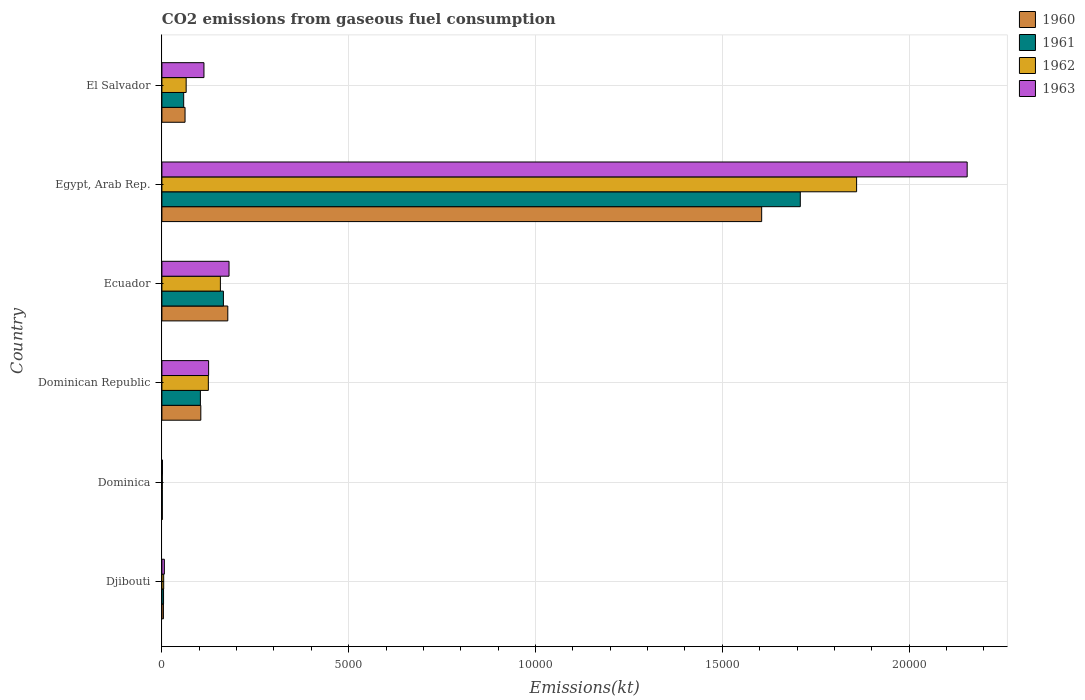How many bars are there on the 4th tick from the bottom?
Ensure brevity in your answer.  4. What is the label of the 1st group of bars from the top?
Provide a succinct answer. El Salvador. What is the amount of CO2 emitted in 1960 in Dominican Republic?
Your answer should be very brief. 1041.43. Across all countries, what is the maximum amount of CO2 emitted in 1960?
Offer a very short reply. 1.61e+04. Across all countries, what is the minimum amount of CO2 emitted in 1961?
Provide a succinct answer. 11. In which country was the amount of CO2 emitted in 1961 maximum?
Your answer should be very brief. Egypt, Arab Rep. In which country was the amount of CO2 emitted in 1963 minimum?
Your answer should be compact. Dominica. What is the total amount of CO2 emitted in 1962 in the graph?
Make the answer very short. 2.21e+04. What is the difference between the amount of CO2 emitted in 1961 in Dominican Republic and that in El Salvador?
Keep it short and to the point. 447.37. What is the difference between the amount of CO2 emitted in 1961 in Dominican Republic and the amount of CO2 emitted in 1963 in El Salvador?
Give a very brief answer. -95.34. What is the average amount of CO2 emitted in 1962 per country?
Your answer should be very brief. 3685.34. What is the difference between the amount of CO2 emitted in 1960 and amount of CO2 emitted in 1962 in Dominican Republic?
Offer a very short reply. -201.68. In how many countries, is the amount of CO2 emitted in 1961 greater than 11000 kt?
Give a very brief answer. 1. What is the ratio of the amount of CO2 emitted in 1963 in Dominican Republic to that in El Salvador?
Provide a short and direct response. 1.11. Is the amount of CO2 emitted in 1960 in Djibouti less than that in El Salvador?
Provide a short and direct response. Yes. What is the difference between the highest and the second highest amount of CO2 emitted in 1960?
Your answer should be compact. 1.43e+04. What is the difference between the highest and the lowest amount of CO2 emitted in 1960?
Make the answer very short. 1.60e+04. In how many countries, is the amount of CO2 emitted in 1960 greater than the average amount of CO2 emitted in 1960 taken over all countries?
Your answer should be compact. 1. Is it the case that in every country, the sum of the amount of CO2 emitted in 1960 and amount of CO2 emitted in 1962 is greater than the sum of amount of CO2 emitted in 1961 and amount of CO2 emitted in 1963?
Ensure brevity in your answer.  No. What does the 1st bar from the bottom in Ecuador represents?
Offer a terse response. 1960. Is it the case that in every country, the sum of the amount of CO2 emitted in 1963 and amount of CO2 emitted in 1960 is greater than the amount of CO2 emitted in 1962?
Offer a very short reply. Yes. Are all the bars in the graph horizontal?
Your answer should be very brief. Yes. Does the graph contain any zero values?
Your response must be concise. No. Does the graph contain grids?
Keep it short and to the point. Yes. How many legend labels are there?
Your answer should be compact. 4. How are the legend labels stacked?
Keep it short and to the point. Vertical. What is the title of the graph?
Keep it short and to the point. CO2 emissions from gaseous fuel consumption. What is the label or title of the X-axis?
Your answer should be compact. Emissions(kt). What is the Emissions(kt) of 1960 in Djibouti?
Make the answer very short. 40.34. What is the Emissions(kt) in 1961 in Djibouti?
Offer a terse response. 44. What is the Emissions(kt) in 1962 in Djibouti?
Your response must be concise. 47.67. What is the Emissions(kt) of 1963 in Djibouti?
Keep it short and to the point. 66.01. What is the Emissions(kt) in 1960 in Dominica?
Make the answer very short. 11. What is the Emissions(kt) in 1961 in Dominica?
Provide a short and direct response. 11. What is the Emissions(kt) in 1962 in Dominica?
Make the answer very short. 11. What is the Emissions(kt) of 1963 in Dominica?
Your answer should be very brief. 14.67. What is the Emissions(kt) in 1960 in Dominican Republic?
Keep it short and to the point. 1041.43. What is the Emissions(kt) of 1961 in Dominican Republic?
Offer a very short reply. 1030.43. What is the Emissions(kt) in 1962 in Dominican Republic?
Your answer should be very brief. 1243.11. What is the Emissions(kt) of 1963 in Dominican Republic?
Provide a succinct answer. 1250.45. What is the Emissions(kt) in 1960 in Ecuador?
Give a very brief answer. 1763.83. What is the Emissions(kt) of 1961 in Ecuador?
Offer a terse response. 1646.48. What is the Emissions(kt) of 1962 in Ecuador?
Your answer should be compact. 1565.81. What is the Emissions(kt) in 1963 in Ecuador?
Provide a succinct answer. 1796.83. What is the Emissions(kt) of 1960 in Egypt, Arab Rep.?
Provide a succinct answer. 1.61e+04. What is the Emissions(kt) of 1961 in Egypt, Arab Rep.?
Make the answer very short. 1.71e+04. What is the Emissions(kt) in 1962 in Egypt, Arab Rep.?
Your answer should be very brief. 1.86e+04. What is the Emissions(kt) of 1963 in Egypt, Arab Rep.?
Your answer should be compact. 2.16e+04. What is the Emissions(kt) in 1960 in El Salvador?
Make the answer very short. 619.72. What is the Emissions(kt) of 1961 in El Salvador?
Your answer should be very brief. 583.05. What is the Emissions(kt) in 1962 in El Salvador?
Offer a terse response. 649.06. What is the Emissions(kt) in 1963 in El Salvador?
Ensure brevity in your answer.  1125.77. Across all countries, what is the maximum Emissions(kt) of 1960?
Offer a very short reply. 1.61e+04. Across all countries, what is the maximum Emissions(kt) of 1961?
Offer a terse response. 1.71e+04. Across all countries, what is the maximum Emissions(kt) in 1962?
Your answer should be compact. 1.86e+04. Across all countries, what is the maximum Emissions(kt) of 1963?
Provide a succinct answer. 2.16e+04. Across all countries, what is the minimum Emissions(kt) of 1960?
Provide a short and direct response. 11. Across all countries, what is the minimum Emissions(kt) in 1961?
Offer a very short reply. 11. Across all countries, what is the minimum Emissions(kt) of 1962?
Keep it short and to the point. 11. Across all countries, what is the minimum Emissions(kt) of 1963?
Provide a succinct answer. 14.67. What is the total Emissions(kt) of 1960 in the graph?
Offer a very short reply. 1.95e+04. What is the total Emissions(kt) of 1961 in the graph?
Give a very brief answer. 2.04e+04. What is the total Emissions(kt) of 1962 in the graph?
Offer a very short reply. 2.21e+04. What is the total Emissions(kt) in 1963 in the graph?
Offer a terse response. 2.58e+04. What is the difference between the Emissions(kt) in 1960 in Djibouti and that in Dominica?
Your answer should be very brief. 29.34. What is the difference between the Emissions(kt) in 1961 in Djibouti and that in Dominica?
Provide a succinct answer. 33. What is the difference between the Emissions(kt) of 1962 in Djibouti and that in Dominica?
Ensure brevity in your answer.  36.67. What is the difference between the Emissions(kt) of 1963 in Djibouti and that in Dominica?
Keep it short and to the point. 51.34. What is the difference between the Emissions(kt) in 1960 in Djibouti and that in Dominican Republic?
Your answer should be very brief. -1001.09. What is the difference between the Emissions(kt) in 1961 in Djibouti and that in Dominican Republic?
Give a very brief answer. -986.42. What is the difference between the Emissions(kt) in 1962 in Djibouti and that in Dominican Republic?
Your answer should be compact. -1195.44. What is the difference between the Emissions(kt) in 1963 in Djibouti and that in Dominican Republic?
Provide a short and direct response. -1184.44. What is the difference between the Emissions(kt) of 1960 in Djibouti and that in Ecuador?
Keep it short and to the point. -1723.49. What is the difference between the Emissions(kt) of 1961 in Djibouti and that in Ecuador?
Provide a succinct answer. -1602.48. What is the difference between the Emissions(kt) of 1962 in Djibouti and that in Ecuador?
Your answer should be very brief. -1518.14. What is the difference between the Emissions(kt) in 1963 in Djibouti and that in Ecuador?
Your response must be concise. -1730.82. What is the difference between the Emissions(kt) of 1960 in Djibouti and that in Egypt, Arab Rep.?
Ensure brevity in your answer.  -1.60e+04. What is the difference between the Emissions(kt) of 1961 in Djibouti and that in Egypt, Arab Rep.?
Make the answer very short. -1.70e+04. What is the difference between the Emissions(kt) in 1962 in Djibouti and that in Egypt, Arab Rep.?
Make the answer very short. -1.85e+04. What is the difference between the Emissions(kt) in 1963 in Djibouti and that in Egypt, Arab Rep.?
Make the answer very short. -2.15e+04. What is the difference between the Emissions(kt) in 1960 in Djibouti and that in El Salvador?
Ensure brevity in your answer.  -579.39. What is the difference between the Emissions(kt) of 1961 in Djibouti and that in El Salvador?
Provide a succinct answer. -539.05. What is the difference between the Emissions(kt) in 1962 in Djibouti and that in El Salvador?
Your answer should be very brief. -601.39. What is the difference between the Emissions(kt) of 1963 in Djibouti and that in El Salvador?
Keep it short and to the point. -1059.76. What is the difference between the Emissions(kt) of 1960 in Dominica and that in Dominican Republic?
Make the answer very short. -1030.43. What is the difference between the Emissions(kt) in 1961 in Dominica and that in Dominican Republic?
Provide a succinct answer. -1019.43. What is the difference between the Emissions(kt) of 1962 in Dominica and that in Dominican Republic?
Make the answer very short. -1232.11. What is the difference between the Emissions(kt) of 1963 in Dominica and that in Dominican Republic?
Your answer should be very brief. -1235.78. What is the difference between the Emissions(kt) of 1960 in Dominica and that in Ecuador?
Provide a succinct answer. -1752.83. What is the difference between the Emissions(kt) of 1961 in Dominica and that in Ecuador?
Your response must be concise. -1635.48. What is the difference between the Emissions(kt) in 1962 in Dominica and that in Ecuador?
Make the answer very short. -1554.81. What is the difference between the Emissions(kt) of 1963 in Dominica and that in Ecuador?
Give a very brief answer. -1782.16. What is the difference between the Emissions(kt) of 1960 in Dominica and that in Egypt, Arab Rep.?
Your answer should be very brief. -1.60e+04. What is the difference between the Emissions(kt) of 1961 in Dominica and that in Egypt, Arab Rep.?
Offer a terse response. -1.71e+04. What is the difference between the Emissions(kt) of 1962 in Dominica and that in Egypt, Arab Rep.?
Offer a very short reply. -1.86e+04. What is the difference between the Emissions(kt) in 1963 in Dominica and that in Egypt, Arab Rep.?
Your answer should be very brief. -2.15e+04. What is the difference between the Emissions(kt) of 1960 in Dominica and that in El Salvador?
Offer a terse response. -608.72. What is the difference between the Emissions(kt) in 1961 in Dominica and that in El Salvador?
Give a very brief answer. -572.05. What is the difference between the Emissions(kt) in 1962 in Dominica and that in El Salvador?
Your answer should be compact. -638.06. What is the difference between the Emissions(kt) of 1963 in Dominica and that in El Salvador?
Your answer should be compact. -1111.1. What is the difference between the Emissions(kt) in 1960 in Dominican Republic and that in Ecuador?
Your response must be concise. -722.4. What is the difference between the Emissions(kt) in 1961 in Dominican Republic and that in Ecuador?
Your response must be concise. -616.06. What is the difference between the Emissions(kt) of 1962 in Dominican Republic and that in Ecuador?
Your answer should be very brief. -322.7. What is the difference between the Emissions(kt) in 1963 in Dominican Republic and that in Ecuador?
Your answer should be compact. -546.38. What is the difference between the Emissions(kt) of 1960 in Dominican Republic and that in Egypt, Arab Rep.?
Make the answer very short. -1.50e+04. What is the difference between the Emissions(kt) in 1961 in Dominican Republic and that in Egypt, Arab Rep.?
Provide a succinct answer. -1.61e+04. What is the difference between the Emissions(kt) of 1962 in Dominican Republic and that in Egypt, Arab Rep.?
Ensure brevity in your answer.  -1.74e+04. What is the difference between the Emissions(kt) in 1963 in Dominican Republic and that in Egypt, Arab Rep.?
Provide a succinct answer. -2.03e+04. What is the difference between the Emissions(kt) of 1960 in Dominican Republic and that in El Salvador?
Provide a short and direct response. 421.7. What is the difference between the Emissions(kt) of 1961 in Dominican Republic and that in El Salvador?
Your answer should be compact. 447.37. What is the difference between the Emissions(kt) in 1962 in Dominican Republic and that in El Salvador?
Offer a very short reply. 594.05. What is the difference between the Emissions(kt) of 1963 in Dominican Republic and that in El Salvador?
Provide a succinct answer. 124.68. What is the difference between the Emissions(kt) of 1960 in Ecuador and that in Egypt, Arab Rep.?
Offer a very short reply. -1.43e+04. What is the difference between the Emissions(kt) of 1961 in Ecuador and that in Egypt, Arab Rep.?
Offer a very short reply. -1.54e+04. What is the difference between the Emissions(kt) of 1962 in Ecuador and that in Egypt, Arab Rep.?
Your response must be concise. -1.70e+04. What is the difference between the Emissions(kt) in 1963 in Ecuador and that in Egypt, Arab Rep.?
Provide a short and direct response. -1.98e+04. What is the difference between the Emissions(kt) of 1960 in Ecuador and that in El Salvador?
Keep it short and to the point. 1144.1. What is the difference between the Emissions(kt) of 1961 in Ecuador and that in El Salvador?
Your answer should be very brief. 1063.43. What is the difference between the Emissions(kt) in 1962 in Ecuador and that in El Salvador?
Provide a short and direct response. 916.75. What is the difference between the Emissions(kt) of 1963 in Ecuador and that in El Salvador?
Provide a succinct answer. 671.06. What is the difference between the Emissions(kt) in 1960 in Egypt, Arab Rep. and that in El Salvador?
Offer a terse response. 1.54e+04. What is the difference between the Emissions(kt) of 1961 in Egypt, Arab Rep. and that in El Salvador?
Provide a succinct answer. 1.65e+04. What is the difference between the Emissions(kt) in 1962 in Egypt, Arab Rep. and that in El Salvador?
Provide a succinct answer. 1.79e+04. What is the difference between the Emissions(kt) in 1963 in Egypt, Arab Rep. and that in El Salvador?
Offer a very short reply. 2.04e+04. What is the difference between the Emissions(kt) of 1960 in Djibouti and the Emissions(kt) of 1961 in Dominica?
Your answer should be compact. 29.34. What is the difference between the Emissions(kt) of 1960 in Djibouti and the Emissions(kt) of 1962 in Dominica?
Your response must be concise. 29.34. What is the difference between the Emissions(kt) in 1960 in Djibouti and the Emissions(kt) in 1963 in Dominica?
Ensure brevity in your answer.  25.67. What is the difference between the Emissions(kt) in 1961 in Djibouti and the Emissions(kt) in 1962 in Dominica?
Your answer should be compact. 33. What is the difference between the Emissions(kt) of 1961 in Djibouti and the Emissions(kt) of 1963 in Dominica?
Give a very brief answer. 29.34. What is the difference between the Emissions(kt) of 1962 in Djibouti and the Emissions(kt) of 1963 in Dominica?
Ensure brevity in your answer.  33. What is the difference between the Emissions(kt) of 1960 in Djibouti and the Emissions(kt) of 1961 in Dominican Republic?
Provide a short and direct response. -990.09. What is the difference between the Emissions(kt) in 1960 in Djibouti and the Emissions(kt) in 1962 in Dominican Republic?
Ensure brevity in your answer.  -1202.78. What is the difference between the Emissions(kt) in 1960 in Djibouti and the Emissions(kt) in 1963 in Dominican Republic?
Make the answer very short. -1210.11. What is the difference between the Emissions(kt) of 1961 in Djibouti and the Emissions(kt) of 1962 in Dominican Republic?
Make the answer very short. -1199.11. What is the difference between the Emissions(kt) in 1961 in Djibouti and the Emissions(kt) in 1963 in Dominican Republic?
Ensure brevity in your answer.  -1206.44. What is the difference between the Emissions(kt) in 1962 in Djibouti and the Emissions(kt) in 1963 in Dominican Republic?
Make the answer very short. -1202.78. What is the difference between the Emissions(kt) in 1960 in Djibouti and the Emissions(kt) in 1961 in Ecuador?
Ensure brevity in your answer.  -1606.15. What is the difference between the Emissions(kt) of 1960 in Djibouti and the Emissions(kt) of 1962 in Ecuador?
Offer a terse response. -1525.47. What is the difference between the Emissions(kt) in 1960 in Djibouti and the Emissions(kt) in 1963 in Ecuador?
Your response must be concise. -1756.49. What is the difference between the Emissions(kt) in 1961 in Djibouti and the Emissions(kt) in 1962 in Ecuador?
Offer a very short reply. -1521.81. What is the difference between the Emissions(kt) in 1961 in Djibouti and the Emissions(kt) in 1963 in Ecuador?
Give a very brief answer. -1752.83. What is the difference between the Emissions(kt) in 1962 in Djibouti and the Emissions(kt) in 1963 in Ecuador?
Your answer should be compact. -1749.16. What is the difference between the Emissions(kt) of 1960 in Djibouti and the Emissions(kt) of 1961 in Egypt, Arab Rep.?
Ensure brevity in your answer.  -1.70e+04. What is the difference between the Emissions(kt) in 1960 in Djibouti and the Emissions(kt) in 1962 in Egypt, Arab Rep.?
Offer a very short reply. -1.86e+04. What is the difference between the Emissions(kt) in 1960 in Djibouti and the Emissions(kt) in 1963 in Egypt, Arab Rep.?
Make the answer very short. -2.15e+04. What is the difference between the Emissions(kt) in 1961 in Djibouti and the Emissions(kt) in 1962 in Egypt, Arab Rep.?
Provide a short and direct response. -1.86e+04. What is the difference between the Emissions(kt) of 1961 in Djibouti and the Emissions(kt) of 1963 in Egypt, Arab Rep.?
Provide a succinct answer. -2.15e+04. What is the difference between the Emissions(kt) of 1962 in Djibouti and the Emissions(kt) of 1963 in Egypt, Arab Rep.?
Offer a very short reply. -2.15e+04. What is the difference between the Emissions(kt) in 1960 in Djibouti and the Emissions(kt) in 1961 in El Salvador?
Your answer should be compact. -542.72. What is the difference between the Emissions(kt) of 1960 in Djibouti and the Emissions(kt) of 1962 in El Salvador?
Offer a very short reply. -608.72. What is the difference between the Emissions(kt) of 1960 in Djibouti and the Emissions(kt) of 1963 in El Salvador?
Provide a short and direct response. -1085.43. What is the difference between the Emissions(kt) of 1961 in Djibouti and the Emissions(kt) of 1962 in El Salvador?
Keep it short and to the point. -605.05. What is the difference between the Emissions(kt) in 1961 in Djibouti and the Emissions(kt) in 1963 in El Salvador?
Your answer should be very brief. -1081.77. What is the difference between the Emissions(kt) of 1962 in Djibouti and the Emissions(kt) of 1963 in El Salvador?
Keep it short and to the point. -1078.1. What is the difference between the Emissions(kt) of 1960 in Dominica and the Emissions(kt) of 1961 in Dominican Republic?
Your response must be concise. -1019.43. What is the difference between the Emissions(kt) in 1960 in Dominica and the Emissions(kt) in 1962 in Dominican Republic?
Provide a short and direct response. -1232.11. What is the difference between the Emissions(kt) of 1960 in Dominica and the Emissions(kt) of 1963 in Dominican Republic?
Your answer should be compact. -1239.45. What is the difference between the Emissions(kt) of 1961 in Dominica and the Emissions(kt) of 1962 in Dominican Republic?
Offer a terse response. -1232.11. What is the difference between the Emissions(kt) of 1961 in Dominica and the Emissions(kt) of 1963 in Dominican Republic?
Make the answer very short. -1239.45. What is the difference between the Emissions(kt) of 1962 in Dominica and the Emissions(kt) of 1963 in Dominican Republic?
Give a very brief answer. -1239.45. What is the difference between the Emissions(kt) of 1960 in Dominica and the Emissions(kt) of 1961 in Ecuador?
Offer a terse response. -1635.48. What is the difference between the Emissions(kt) in 1960 in Dominica and the Emissions(kt) in 1962 in Ecuador?
Your answer should be very brief. -1554.81. What is the difference between the Emissions(kt) of 1960 in Dominica and the Emissions(kt) of 1963 in Ecuador?
Ensure brevity in your answer.  -1785.83. What is the difference between the Emissions(kt) of 1961 in Dominica and the Emissions(kt) of 1962 in Ecuador?
Your answer should be compact. -1554.81. What is the difference between the Emissions(kt) of 1961 in Dominica and the Emissions(kt) of 1963 in Ecuador?
Your response must be concise. -1785.83. What is the difference between the Emissions(kt) in 1962 in Dominica and the Emissions(kt) in 1963 in Ecuador?
Ensure brevity in your answer.  -1785.83. What is the difference between the Emissions(kt) of 1960 in Dominica and the Emissions(kt) of 1961 in Egypt, Arab Rep.?
Your response must be concise. -1.71e+04. What is the difference between the Emissions(kt) of 1960 in Dominica and the Emissions(kt) of 1962 in Egypt, Arab Rep.?
Offer a very short reply. -1.86e+04. What is the difference between the Emissions(kt) in 1960 in Dominica and the Emissions(kt) in 1963 in Egypt, Arab Rep.?
Offer a very short reply. -2.15e+04. What is the difference between the Emissions(kt) in 1961 in Dominica and the Emissions(kt) in 1962 in Egypt, Arab Rep.?
Give a very brief answer. -1.86e+04. What is the difference between the Emissions(kt) of 1961 in Dominica and the Emissions(kt) of 1963 in Egypt, Arab Rep.?
Offer a terse response. -2.15e+04. What is the difference between the Emissions(kt) of 1962 in Dominica and the Emissions(kt) of 1963 in Egypt, Arab Rep.?
Provide a succinct answer. -2.15e+04. What is the difference between the Emissions(kt) of 1960 in Dominica and the Emissions(kt) of 1961 in El Salvador?
Give a very brief answer. -572.05. What is the difference between the Emissions(kt) in 1960 in Dominica and the Emissions(kt) in 1962 in El Salvador?
Give a very brief answer. -638.06. What is the difference between the Emissions(kt) in 1960 in Dominica and the Emissions(kt) in 1963 in El Salvador?
Your answer should be very brief. -1114.77. What is the difference between the Emissions(kt) of 1961 in Dominica and the Emissions(kt) of 1962 in El Salvador?
Provide a short and direct response. -638.06. What is the difference between the Emissions(kt) of 1961 in Dominica and the Emissions(kt) of 1963 in El Salvador?
Make the answer very short. -1114.77. What is the difference between the Emissions(kt) of 1962 in Dominica and the Emissions(kt) of 1963 in El Salvador?
Make the answer very short. -1114.77. What is the difference between the Emissions(kt) of 1960 in Dominican Republic and the Emissions(kt) of 1961 in Ecuador?
Provide a succinct answer. -605.05. What is the difference between the Emissions(kt) in 1960 in Dominican Republic and the Emissions(kt) in 1962 in Ecuador?
Make the answer very short. -524.38. What is the difference between the Emissions(kt) of 1960 in Dominican Republic and the Emissions(kt) of 1963 in Ecuador?
Your answer should be very brief. -755.4. What is the difference between the Emissions(kt) in 1961 in Dominican Republic and the Emissions(kt) in 1962 in Ecuador?
Give a very brief answer. -535.38. What is the difference between the Emissions(kt) of 1961 in Dominican Republic and the Emissions(kt) of 1963 in Ecuador?
Offer a terse response. -766.4. What is the difference between the Emissions(kt) of 1962 in Dominican Republic and the Emissions(kt) of 1963 in Ecuador?
Offer a very short reply. -553.72. What is the difference between the Emissions(kt) in 1960 in Dominican Republic and the Emissions(kt) in 1961 in Egypt, Arab Rep.?
Ensure brevity in your answer.  -1.60e+04. What is the difference between the Emissions(kt) of 1960 in Dominican Republic and the Emissions(kt) of 1962 in Egypt, Arab Rep.?
Offer a terse response. -1.76e+04. What is the difference between the Emissions(kt) in 1960 in Dominican Republic and the Emissions(kt) in 1963 in Egypt, Arab Rep.?
Give a very brief answer. -2.05e+04. What is the difference between the Emissions(kt) in 1961 in Dominican Republic and the Emissions(kt) in 1962 in Egypt, Arab Rep.?
Give a very brief answer. -1.76e+04. What is the difference between the Emissions(kt) in 1961 in Dominican Republic and the Emissions(kt) in 1963 in Egypt, Arab Rep.?
Keep it short and to the point. -2.05e+04. What is the difference between the Emissions(kt) of 1962 in Dominican Republic and the Emissions(kt) of 1963 in Egypt, Arab Rep.?
Offer a terse response. -2.03e+04. What is the difference between the Emissions(kt) in 1960 in Dominican Republic and the Emissions(kt) in 1961 in El Salvador?
Provide a short and direct response. 458.38. What is the difference between the Emissions(kt) of 1960 in Dominican Republic and the Emissions(kt) of 1962 in El Salvador?
Give a very brief answer. 392.37. What is the difference between the Emissions(kt) in 1960 in Dominican Republic and the Emissions(kt) in 1963 in El Salvador?
Your answer should be very brief. -84.34. What is the difference between the Emissions(kt) of 1961 in Dominican Republic and the Emissions(kt) of 1962 in El Salvador?
Make the answer very short. 381.37. What is the difference between the Emissions(kt) of 1961 in Dominican Republic and the Emissions(kt) of 1963 in El Salvador?
Your answer should be compact. -95.34. What is the difference between the Emissions(kt) of 1962 in Dominican Republic and the Emissions(kt) of 1963 in El Salvador?
Provide a short and direct response. 117.34. What is the difference between the Emissions(kt) in 1960 in Ecuador and the Emissions(kt) in 1961 in Egypt, Arab Rep.?
Your answer should be compact. -1.53e+04. What is the difference between the Emissions(kt) of 1960 in Ecuador and the Emissions(kt) of 1962 in Egypt, Arab Rep.?
Give a very brief answer. -1.68e+04. What is the difference between the Emissions(kt) in 1960 in Ecuador and the Emissions(kt) in 1963 in Egypt, Arab Rep.?
Offer a very short reply. -1.98e+04. What is the difference between the Emissions(kt) of 1961 in Ecuador and the Emissions(kt) of 1962 in Egypt, Arab Rep.?
Ensure brevity in your answer.  -1.69e+04. What is the difference between the Emissions(kt) in 1961 in Ecuador and the Emissions(kt) in 1963 in Egypt, Arab Rep.?
Keep it short and to the point. -1.99e+04. What is the difference between the Emissions(kt) of 1962 in Ecuador and the Emissions(kt) of 1963 in Egypt, Arab Rep.?
Give a very brief answer. -2.00e+04. What is the difference between the Emissions(kt) of 1960 in Ecuador and the Emissions(kt) of 1961 in El Salvador?
Ensure brevity in your answer.  1180.77. What is the difference between the Emissions(kt) in 1960 in Ecuador and the Emissions(kt) in 1962 in El Salvador?
Your answer should be very brief. 1114.77. What is the difference between the Emissions(kt) in 1960 in Ecuador and the Emissions(kt) in 1963 in El Salvador?
Make the answer very short. 638.06. What is the difference between the Emissions(kt) of 1961 in Ecuador and the Emissions(kt) of 1962 in El Salvador?
Provide a succinct answer. 997.42. What is the difference between the Emissions(kt) in 1961 in Ecuador and the Emissions(kt) in 1963 in El Salvador?
Offer a very short reply. 520.71. What is the difference between the Emissions(kt) of 1962 in Ecuador and the Emissions(kt) of 1963 in El Salvador?
Provide a succinct answer. 440.04. What is the difference between the Emissions(kt) of 1960 in Egypt, Arab Rep. and the Emissions(kt) of 1961 in El Salvador?
Offer a very short reply. 1.55e+04. What is the difference between the Emissions(kt) in 1960 in Egypt, Arab Rep. and the Emissions(kt) in 1962 in El Salvador?
Give a very brief answer. 1.54e+04. What is the difference between the Emissions(kt) in 1960 in Egypt, Arab Rep. and the Emissions(kt) in 1963 in El Salvador?
Give a very brief answer. 1.49e+04. What is the difference between the Emissions(kt) in 1961 in Egypt, Arab Rep. and the Emissions(kt) in 1962 in El Salvador?
Make the answer very short. 1.64e+04. What is the difference between the Emissions(kt) in 1961 in Egypt, Arab Rep. and the Emissions(kt) in 1963 in El Salvador?
Offer a terse response. 1.60e+04. What is the difference between the Emissions(kt) in 1962 in Egypt, Arab Rep. and the Emissions(kt) in 1963 in El Salvador?
Ensure brevity in your answer.  1.75e+04. What is the average Emissions(kt) of 1960 per country?
Your answer should be very brief. 3255.07. What is the average Emissions(kt) of 1961 per country?
Your response must be concise. 3400.53. What is the average Emissions(kt) in 1962 per country?
Your answer should be very brief. 3685.34. What is the average Emissions(kt) of 1963 per country?
Your answer should be compact. 4301.39. What is the difference between the Emissions(kt) of 1960 and Emissions(kt) of 1961 in Djibouti?
Your answer should be very brief. -3.67. What is the difference between the Emissions(kt) in 1960 and Emissions(kt) in 1962 in Djibouti?
Provide a short and direct response. -7.33. What is the difference between the Emissions(kt) in 1960 and Emissions(kt) in 1963 in Djibouti?
Offer a terse response. -25.67. What is the difference between the Emissions(kt) in 1961 and Emissions(kt) in 1962 in Djibouti?
Keep it short and to the point. -3.67. What is the difference between the Emissions(kt) in 1961 and Emissions(kt) in 1963 in Djibouti?
Your answer should be compact. -22. What is the difference between the Emissions(kt) in 1962 and Emissions(kt) in 1963 in Djibouti?
Keep it short and to the point. -18.34. What is the difference between the Emissions(kt) of 1960 and Emissions(kt) of 1961 in Dominica?
Keep it short and to the point. 0. What is the difference between the Emissions(kt) in 1960 and Emissions(kt) in 1962 in Dominica?
Provide a short and direct response. 0. What is the difference between the Emissions(kt) in 1960 and Emissions(kt) in 1963 in Dominica?
Keep it short and to the point. -3.67. What is the difference between the Emissions(kt) in 1961 and Emissions(kt) in 1962 in Dominica?
Your answer should be compact. 0. What is the difference between the Emissions(kt) of 1961 and Emissions(kt) of 1963 in Dominica?
Offer a very short reply. -3.67. What is the difference between the Emissions(kt) of 1962 and Emissions(kt) of 1963 in Dominica?
Offer a very short reply. -3.67. What is the difference between the Emissions(kt) in 1960 and Emissions(kt) in 1961 in Dominican Republic?
Offer a very short reply. 11. What is the difference between the Emissions(kt) of 1960 and Emissions(kt) of 1962 in Dominican Republic?
Ensure brevity in your answer.  -201.69. What is the difference between the Emissions(kt) in 1960 and Emissions(kt) in 1963 in Dominican Republic?
Provide a short and direct response. -209.02. What is the difference between the Emissions(kt) in 1961 and Emissions(kt) in 1962 in Dominican Republic?
Ensure brevity in your answer.  -212.69. What is the difference between the Emissions(kt) in 1961 and Emissions(kt) in 1963 in Dominican Republic?
Provide a short and direct response. -220.02. What is the difference between the Emissions(kt) in 1962 and Emissions(kt) in 1963 in Dominican Republic?
Provide a succinct answer. -7.33. What is the difference between the Emissions(kt) of 1960 and Emissions(kt) of 1961 in Ecuador?
Ensure brevity in your answer.  117.34. What is the difference between the Emissions(kt) in 1960 and Emissions(kt) in 1962 in Ecuador?
Your response must be concise. 198.02. What is the difference between the Emissions(kt) of 1960 and Emissions(kt) of 1963 in Ecuador?
Your answer should be compact. -33. What is the difference between the Emissions(kt) in 1961 and Emissions(kt) in 1962 in Ecuador?
Offer a very short reply. 80.67. What is the difference between the Emissions(kt) in 1961 and Emissions(kt) in 1963 in Ecuador?
Make the answer very short. -150.35. What is the difference between the Emissions(kt) in 1962 and Emissions(kt) in 1963 in Ecuador?
Make the answer very short. -231.02. What is the difference between the Emissions(kt) of 1960 and Emissions(kt) of 1961 in Egypt, Arab Rep.?
Ensure brevity in your answer.  -1034.09. What is the difference between the Emissions(kt) of 1960 and Emissions(kt) of 1962 in Egypt, Arab Rep.?
Your answer should be compact. -2541.23. What is the difference between the Emissions(kt) in 1960 and Emissions(kt) in 1963 in Egypt, Arab Rep.?
Give a very brief answer. -5500.5. What is the difference between the Emissions(kt) in 1961 and Emissions(kt) in 1962 in Egypt, Arab Rep.?
Provide a succinct answer. -1507.14. What is the difference between the Emissions(kt) of 1961 and Emissions(kt) of 1963 in Egypt, Arab Rep.?
Make the answer very short. -4466.41. What is the difference between the Emissions(kt) in 1962 and Emissions(kt) in 1963 in Egypt, Arab Rep.?
Your response must be concise. -2959.27. What is the difference between the Emissions(kt) in 1960 and Emissions(kt) in 1961 in El Salvador?
Provide a short and direct response. 36.67. What is the difference between the Emissions(kt) in 1960 and Emissions(kt) in 1962 in El Salvador?
Keep it short and to the point. -29.34. What is the difference between the Emissions(kt) of 1960 and Emissions(kt) of 1963 in El Salvador?
Your answer should be compact. -506.05. What is the difference between the Emissions(kt) in 1961 and Emissions(kt) in 1962 in El Salvador?
Your response must be concise. -66.01. What is the difference between the Emissions(kt) of 1961 and Emissions(kt) of 1963 in El Salvador?
Give a very brief answer. -542.72. What is the difference between the Emissions(kt) in 1962 and Emissions(kt) in 1963 in El Salvador?
Provide a short and direct response. -476.71. What is the ratio of the Emissions(kt) of 1960 in Djibouti to that in Dominica?
Your answer should be compact. 3.67. What is the ratio of the Emissions(kt) of 1962 in Djibouti to that in Dominica?
Keep it short and to the point. 4.33. What is the ratio of the Emissions(kt) of 1960 in Djibouti to that in Dominican Republic?
Provide a short and direct response. 0.04. What is the ratio of the Emissions(kt) of 1961 in Djibouti to that in Dominican Republic?
Ensure brevity in your answer.  0.04. What is the ratio of the Emissions(kt) in 1962 in Djibouti to that in Dominican Republic?
Make the answer very short. 0.04. What is the ratio of the Emissions(kt) in 1963 in Djibouti to that in Dominican Republic?
Offer a terse response. 0.05. What is the ratio of the Emissions(kt) of 1960 in Djibouti to that in Ecuador?
Make the answer very short. 0.02. What is the ratio of the Emissions(kt) in 1961 in Djibouti to that in Ecuador?
Make the answer very short. 0.03. What is the ratio of the Emissions(kt) in 1962 in Djibouti to that in Ecuador?
Your answer should be compact. 0.03. What is the ratio of the Emissions(kt) in 1963 in Djibouti to that in Ecuador?
Make the answer very short. 0.04. What is the ratio of the Emissions(kt) in 1960 in Djibouti to that in Egypt, Arab Rep.?
Offer a terse response. 0. What is the ratio of the Emissions(kt) in 1961 in Djibouti to that in Egypt, Arab Rep.?
Provide a short and direct response. 0. What is the ratio of the Emissions(kt) of 1962 in Djibouti to that in Egypt, Arab Rep.?
Provide a short and direct response. 0. What is the ratio of the Emissions(kt) of 1963 in Djibouti to that in Egypt, Arab Rep.?
Offer a terse response. 0. What is the ratio of the Emissions(kt) of 1960 in Djibouti to that in El Salvador?
Your answer should be very brief. 0.07. What is the ratio of the Emissions(kt) in 1961 in Djibouti to that in El Salvador?
Your response must be concise. 0.08. What is the ratio of the Emissions(kt) in 1962 in Djibouti to that in El Salvador?
Keep it short and to the point. 0.07. What is the ratio of the Emissions(kt) in 1963 in Djibouti to that in El Salvador?
Your answer should be compact. 0.06. What is the ratio of the Emissions(kt) in 1960 in Dominica to that in Dominican Republic?
Ensure brevity in your answer.  0.01. What is the ratio of the Emissions(kt) of 1961 in Dominica to that in Dominican Republic?
Your answer should be compact. 0.01. What is the ratio of the Emissions(kt) of 1962 in Dominica to that in Dominican Republic?
Provide a short and direct response. 0.01. What is the ratio of the Emissions(kt) of 1963 in Dominica to that in Dominican Republic?
Ensure brevity in your answer.  0.01. What is the ratio of the Emissions(kt) of 1960 in Dominica to that in Ecuador?
Provide a short and direct response. 0.01. What is the ratio of the Emissions(kt) in 1961 in Dominica to that in Ecuador?
Keep it short and to the point. 0.01. What is the ratio of the Emissions(kt) of 1962 in Dominica to that in Ecuador?
Give a very brief answer. 0.01. What is the ratio of the Emissions(kt) of 1963 in Dominica to that in Ecuador?
Provide a succinct answer. 0.01. What is the ratio of the Emissions(kt) in 1960 in Dominica to that in Egypt, Arab Rep.?
Provide a succinct answer. 0. What is the ratio of the Emissions(kt) of 1961 in Dominica to that in Egypt, Arab Rep.?
Your answer should be very brief. 0. What is the ratio of the Emissions(kt) in 1962 in Dominica to that in Egypt, Arab Rep.?
Your response must be concise. 0. What is the ratio of the Emissions(kt) in 1963 in Dominica to that in Egypt, Arab Rep.?
Give a very brief answer. 0. What is the ratio of the Emissions(kt) in 1960 in Dominica to that in El Salvador?
Provide a short and direct response. 0.02. What is the ratio of the Emissions(kt) in 1961 in Dominica to that in El Salvador?
Your answer should be very brief. 0.02. What is the ratio of the Emissions(kt) in 1962 in Dominica to that in El Salvador?
Your response must be concise. 0.02. What is the ratio of the Emissions(kt) of 1963 in Dominica to that in El Salvador?
Your answer should be compact. 0.01. What is the ratio of the Emissions(kt) in 1960 in Dominican Republic to that in Ecuador?
Ensure brevity in your answer.  0.59. What is the ratio of the Emissions(kt) in 1961 in Dominican Republic to that in Ecuador?
Make the answer very short. 0.63. What is the ratio of the Emissions(kt) of 1962 in Dominican Republic to that in Ecuador?
Ensure brevity in your answer.  0.79. What is the ratio of the Emissions(kt) in 1963 in Dominican Republic to that in Ecuador?
Your answer should be compact. 0.7. What is the ratio of the Emissions(kt) in 1960 in Dominican Republic to that in Egypt, Arab Rep.?
Offer a very short reply. 0.06. What is the ratio of the Emissions(kt) of 1961 in Dominican Republic to that in Egypt, Arab Rep.?
Your answer should be compact. 0.06. What is the ratio of the Emissions(kt) of 1962 in Dominican Republic to that in Egypt, Arab Rep.?
Your answer should be very brief. 0.07. What is the ratio of the Emissions(kt) of 1963 in Dominican Republic to that in Egypt, Arab Rep.?
Offer a terse response. 0.06. What is the ratio of the Emissions(kt) of 1960 in Dominican Republic to that in El Salvador?
Give a very brief answer. 1.68. What is the ratio of the Emissions(kt) in 1961 in Dominican Republic to that in El Salvador?
Make the answer very short. 1.77. What is the ratio of the Emissions(kt) in 1962 in Dominican Republic to that in El Salvador?
Keep it short and to the point. 1.92. What is the ratio of the Emissions(kt) in 1963 in Dominican Republic to that in El Salvador?
Ensure brevity in your answer.  1.11. What is the ratio of the Emissions(kt) in 1960 in Ecuador to that in Egypt, Arab Rep.?
Offer a terse response. 0.11. What is the ratio of the Emissions(kt) in 1961 in Ecuador to that in Egypt, Arab Rep.?
Your answer should be very brief. 0.1. What is the ratio of the Emissions(kt) of 1962 in Ecuador to that in Egypt, Arab Rep.?
Offer a terse response. 0.08. What is the ratio of the Emissions(kt) of 1963 in Ecuador to that in Egypt, Arab Rep.?
Your answer should be compact. 0.08. What is the ratio of the Emissions(kt) of 1960 in Ecuador to that in El Salvador?
Ensure brevity in your answer.  2.85. What is the ratio of the Emissions(kt) in 1961 in Ecuador to that in El Salvador?
Your response must be concise. 2.82. What is the ratio of the Emissions(kt) in 1962 in Ecuador to that in El Salvador?
Provide a short and direct response. 2.41. What is the ratio of the Emissions(kt) of 1963 in Ecuador to that in El Salvador?
Ensure brevity in your answer.  1.6. What is the ratio of the Emissions(kt) of 1960 in Egypt, Arab Rep. to that in El Salvador?
Keep it short and to the point. 25.91. What is the ratio of the Emissions(kt) in 1961 in Egypt, Arab Rep. to that in El Salvador?
Your answer should be very brief. 29.31. What is the ratio of the Emissions(kt) of 1962 in Egypt, Arab Rep. to that in El Salvador?
Provide a short and direct response. 28.65. What is the ratio of the Emissions(kt) in 1963 in Egypt, Arab Rep. to that in El Salvador?
Make the answer very short. 19.15. What is the difference between the highest and the second highest Emissions(kt) of 1960?
Provide a succinct answer. 1.43e+04. What is the difference between the highest and the second highest Emissions(kt) in 1961?
Your answer should be very brief. 1.54e+04. What is the difference between the highest and the second highest Emissions(kt) of 1962?
Make the answer very short. 1.70e+04. What is the difference between the highest and the second highest Emissions(kt) of 1963?
Ensure brevity in your answer.  1.98e+04. What is the difference between the highest and the lowest Emissions(kt) in 1960?
Your answer should be compact. 1.60e+04. What is the difference between the highest and the lowest Emissions(kt) of 1961?
Your response must be concise. 1.71e+04. What is the difference between the highest and the lowest Emissions(kt) of 1962?
Keep it short and to the point. 1.86e+04. What is the difference between the highest and the lowest Emissions(kt) of 1963?
Offer a very short reply. 2.15e+04. 